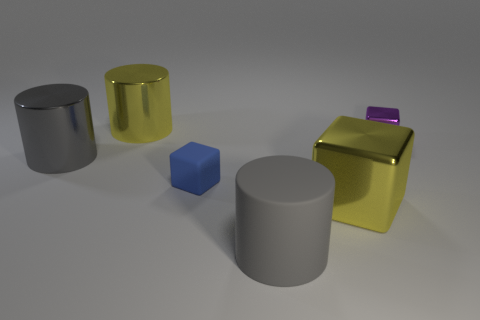Add 1 big rubber cylinders. How many objects exist? 7 Add 6 small blue blocks. How many small blue blocks exist? 7 Subtract 1 purple cubes. How many objects are left? 5 Subtract all large yellow shiny things. Subtract all big gray matte cylinders. How many objects are left? 3 Add 2 small purple cubes. How many small purple cubes are left? 3 